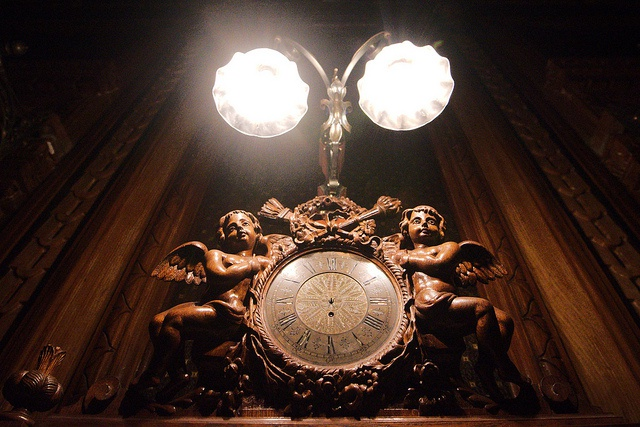Describe the objects in this image and their specific colors. I can see a clock in black, tan, and gray tones in this image. 